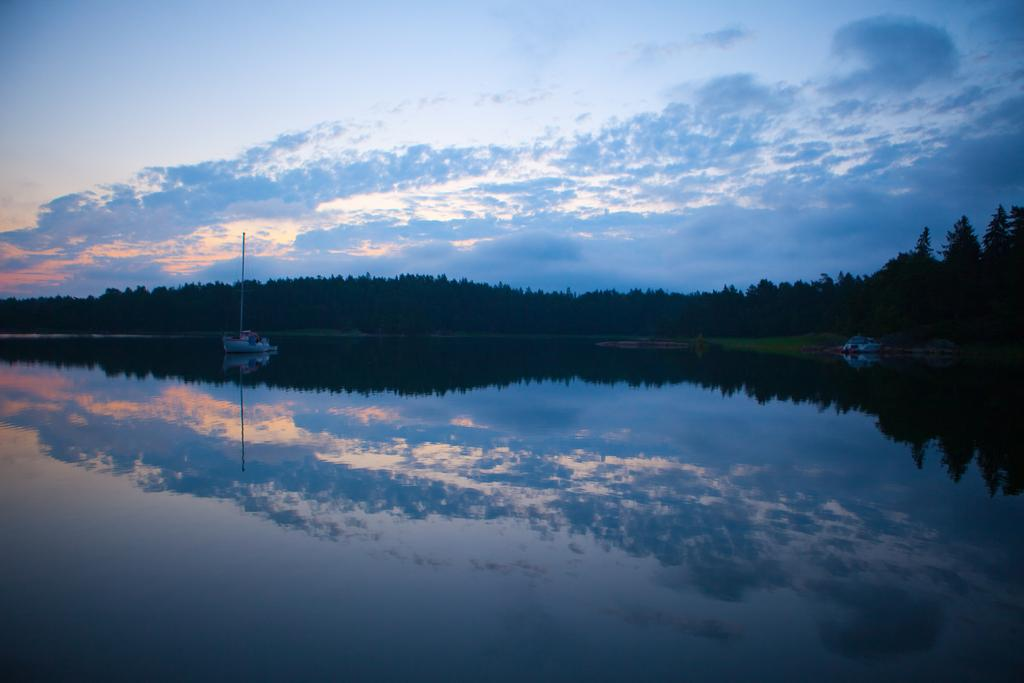What type of vehicles are in the image? There are boats in the image. Where are the boats located? The boats are on the water. What type of vegetation is present in the image? There are trees and grass in the image. What part of the natural environment is visible in the image? The sky is visible in the image. Can you describe the collar on the stranger's pet in the image? There is no stranger or pet present in the image, so there is no collar to describe. 